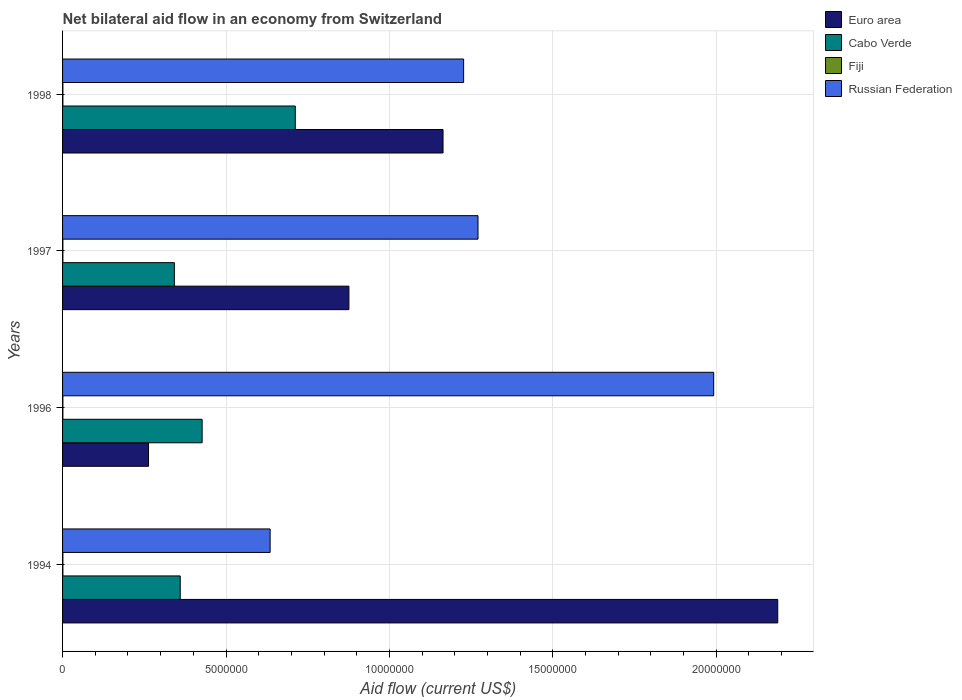How many groups of bars are there?
Offer a very short reply. 4. Are the number of bars per tick equal to the number of legend labels?
Provide a short and direct response. Yes. Are the number of bars on each tick of the Y-axis equal?
Provide a succinct answer. Yes. What is the label of the 4th group of bars from the top?
Keep it short and to the point. 1994. In how many cases, is the number of bars for a given year not equal to the number of legend labels?
Your answer should be compact. 0. What is the net bilateral aid flow in Fiji in 1996?
Offer a very short reply. 10000. Across all years, what is the maximum net bilateral aid flow in Russian Federation?
Give a very brief answer. 1.99e+07. Across all years, what is the minimum net bilateral aid flow in Cabo Verde?
Offer a terse response. 3.42e+06. In which year was the net bilateral aid flow in Fiji minimum?
Make the answer very short. 1994. What is the total net bilateral aid flow in Cabo Verde in the graph?
Your response must be concise. 1.84e+07. What is the difference between the net bilateral aid flow in Euro area in 1994 and that in 1996?
Your answer should be compact. 1.92e+07. What is the difference between the net bilateral aid flow in Russian Federation in 1994 and the net bilateral aid flow in Euro area in 1998?
Make the answer very short. -5.29e+06. What is the average net bilateral aid flow in Fiji per year?
Provide a succinct answer. 10000. In the year 1998, what is the difference between the net bilateral aid flow in Russian Federation and net bilateral aid flow in Euro area?
Provide a short and direct response. 6.30e+05. In how many years, is the net bilateral aid flow in Russian Federation greater than 8000000 US$?
Offer a terse response. 3. Is the difference between the net bilateral aid flow in Russian Federation in 1994 and 1997 greater than the difference between the net bilateral aid flow in Euro area in 1994 and 1997?
Offer a terse response. No. What is the difference between the highest and the second highest net bilateral aid flow in Cabo Verde?
Give a very brief answer. 2.85e+06. What is the difference between the highest and the lowest net bilateral aid flow in Euro area?
Your answer should be very brief. 1.92e+07. In how many years, is the net bilateral aid flow in Cabo Verde greater than the average net bilateral aid flow in Cabo Verde taken over all years?
Make the answer very short. 1. Is it the case that in every year, the sum of the net bilateral aid flow in Fiji and net bilateral aid flow in Cabo Verde is greater than the sum of net bilateral aid flow in Russian Federation and net bilateral aid flow in Euro area?
Make the answer very short. No. What does the 1st bar from the top in 1996 represents?
Ensure brevity in your answer.  Russian Federation. What does the 3rd bar from the bottom in 1997 represents?
Your response must be concise. Fiji. Is it the case that in every year, the sum of the net bilateral aid flow in Cabo Verde and net bilateral aid flow in Russian Federation is greater than the net bilateral aid flow in Fiji?
Give a very brief answer. Yes. Are all the bars in the graph horizontal?
Provide a short and direct response. Yes. Are the values on the major ticks of X-axis written in scientific E-notation?
Provide a succinct answer. No. Where does the legend appear in the graph?
Ensure brevity in your answer.  Top right. How are the legend labels stacked?
Provide a succinct answer. Vertical. What is the title of the graph?
Give a very brief answer. Net bilateral aid flow in an economy from Switzerland. What is the label or title of the X-axis?
Make the answer very short. Aid flow (current US$). What is the Aid flow (current US$) in Euro area in 1994?
Your answer should be very brief. 2.19e+07. What is the Aid flow (current US$) in Cabo Verde in 1994?
Give a very brief answer. 3.60e+06. What is the Aid flow (current US$) of Russian Federation in 1994?
Give a very brief answer. 6.35e+06. What is the Aid flow (current US$) of Euro area in 1996?
Provide a short and direct response. 2.63e+06. What is the Aid flow (current US$) in Cabo Verde in 1996?
Your answer should be compact. 4.27e+06. What is the Aid flow (current US$) in Russian Federation in 1996?
Offer a very short reply. 1.99e+07. What is the Aid flow (current US$) in Euro area in 1997?
Offer a terse response. 8.76e+06. What is the Aid flow (current US$) in Cabo Verde in 1997?
Provide a short and direct response. 3.42e+06. What is the Aid flow (current US$) of Fiji in 1997?
Offer a very short reply. 10000. What is the Aid flow (current US$) of Russian Federation in 1997?
Your response must be concise. 1.27e+07. What is the Aid flow (current US$) of Euro area in 1998?
Provide a succinct answer. 1.16e+07. What is the Aid flow (current US$) of Cabo Verde in 1998?
Ensure brevity in your answer.  7.12e+06. What is the Aid flow (current US$) of Russian Federation in 1998?
Offer a very short reply. 1.23e+07. Across all years, what is the maximum Aid flow (current US$) in Euro area?
Your answer should be very brief. 2.19e+07. Across all years, what is the maximum Aid flow (current US$) in Cabo Verde?
Make the answer very short. 7.12e+06. Across all years, what is the maximum Aid flow (current US$) in Russian Federation?
Give a very brief answer. 1.99e+07. Across all years, what is the minimum Aid flow (current US$) of Euro area?
Your answer should be very brief. 2.63e+06. Across all years, what is the minimum Aid flow (current US$) of Cabo Verde?
Offer a terse response. 3.42e+06. Across all years, what is the minimum Aid flow (current US$) of Russian Federation?
Offer a terse response. 6.35e+06. What is the total Aid flow (current US$) of Euro area in the graph?
Provide a succinct answer. 4.49e+07. What is the total Aid flow (current US$) of Cabo Verde in the graph?
Offer a very short reply. 1.84e+07. What is the total Aid flow (current US$) of Fiji in the graph?
Provide a succinct answer. 4.00e+04. What is the total Aid flow (current US$) of Russian Federation in the graph?
Keep it short and to the point. 5.12e+07. What is the difference between the Aid flow (current US$) of Euro area in 1994 and that in 1996?
Your answer should be compact. 1.92e+07. What is the difference between the Aid flow (current US$) in Cabo Verde in 1994 and that in 1996?
Provide a short and direct response. -6.70e+05. What is the difference between the Aid flow (current US$) in Fiji in 1994 and that in 1996?
Your answer should be very brief. 0. What is the difference between the Aid flow (current US$) of Russian Federation in 1994 and that in 1996?
Keep it short and to the point. -1.36e+07. What is the difference between the Aid flow (current US$) in Euro area in 1994 and that in 1997?
Make the answer very short. 1.31e+07. What is the difference between the Aid flow (current US$) in Russian Federation in 1994 and that in 1997?
Provide a short and direct response. -6.36e+06. What is the difference between the Aid flow (current US$) of Euro area in 1994 and that in 1998?
Offer a terse response. 1.02e+07. What is the difference between the Aid flow (current US$) in Cabo Verde in 1994 and that in 1998?
Keep it short and to the point. -3.52e+06. What is the difference between the Aid flow (current US$) of Fiji in 1994 and that in 1998?
Provide a short and direct response. 0. What is the difference between the Aid flow (current US$) of Russian Federation in 1994 and that in 1998?
Your response must be concise. -5.92e+06. What is the difference between the Aid flow (current US$) in Euro area in 1996 and that in 1997?
Give a very brief answer. -6.13e+06. What is the difference between the Aid flow (current US$) in Cabo Verde in 1996 and that in 1997?
Make the answer very short. 8.50e+05. What is the difference between the Aid flow (current US$) in Russian Federation in 1996 and that in 1997?
Offer a terse response. 7.21e+06. What is the difference between the Aid flow (current US$) in Euro area in 1996 and that in 1998?
Ensure brevity in your answer.  -9.01e+06. What is the difference between the Aid flow (current US$) of Cabo Verde in 1996 and that in 1998?
Offer a terse response. -2.85e+06. What is the difference between the Aid flow (current US$) of Fiji in 1996 and that in 1998?
Make the answer very short. 0. What is the difference between the Aid flow (current US$) in Russian Federation in 1996 and that in 1998?
Provide a short and direct response. 7.65e+06. What is the difference between the Aid flow (current US$) in Euro area in 1997 and that in 1998?
Provide a short and direct response. -2.88e+06. What is the difference between the Aid flow (current US$) of Cabo Verde in 1997 and that in 1998?
Offer a very short reply. -3.70e+06. What is the difference between the Aid flow (current US$) in Fiji in 1997 and that in 1998?
Your response must be concise. 0. What is the difference between the Aid flow (current US$) of Russian Federation in 1997 and that in 1998?
Make the answer very short. 4.40e+05. What is the difference between the Aid flow (current US$) of Euro area in 1994 and the Aid flow (current US$) of Cabo Verde in 1996?
Keep it short and to the point. 1.76e+07. What is the difference between the Aid flow (current US$) of Euro area in 1994 and the Aid flow (current US$) of Fiji in 1996?
Provide a short and direct response. 2.19e+07. What is the difference between the Aid flow (current US$) in Euro area in 1994 and the Aid flow (current US$) in Russian Federation in 1996?
Ensure brevity in your answer.  1.96e+06. What is the difference between the Aid flow (current US$) in Cabo Verde in 1994 and the Aid flow (current US$) in Fiji in 1996?
Keep it short and to the point. 3.59e+06. What is the difference between the Aid flow (current US$) of Cabo Verde in 1994 and the Aid flow (current US$) of Russian Federation in 1996?
Your response must be concise. -1.63e+07. What is the difference between the Aid flow (current US$) in Fiji in 1994 and the Aid flow (current US$) in Russian Federation in 1996?
Make the answer very short. -1.99e+07. What is the difference between the Aid flow (current US$) in Euro area in 1994 and the Aid flow (current US$) in Cabo Verde in 1997?
Ensure brevity in your answer.  1.85e+07. What is the difference between the Aid flow (current US$) of Euro area in 1994 and the Aid flow (current US$) of Fiji in 1997?
Make the answer very short. 2.19e+07. What is the difference between the Aid flow (current US$) of Euro area in 1994 and the Aid flow (current US$) of Russian Federation in 1997?
Give a very brief answer. 9.17e+06. What is the difference between the Aid flow (current US$) of Cabo Verde in 1994 and the Aid flow (current US$) of Fiji in 1997?
Your response must be concise. 3.59e+06. What is the difference between the Aid flow (current US$) of Cabo Verde in 1994 and the Aid flow (current US$) of Russian Federation in 1997?
Your response must be concise. -9.11e+06. What is the difference between the Aid flow (current US$) in Fiji in 1994 and the Aid flow (current US$) in Russian Federation in 1997?
Provide a succinct answer. -1.27e+07. What is the difference between the Aid flow (current US$) of Euro area in 1994 and the Aid flow (current US$) of Cabo Verde in 1998?
Give a very brief answer. 1.48e+07. What is the difference between the Aid flow (current US$) in Euro area in 1994 and the Aid flow (current US$) in Fiji in 1998?
Make the answer very short. 2.19e+07. What is the difference between the Aid flow (current US$) of Euro area in 1994 and the Aid flow (current US$) of Russian Federation in 1998?
Your answer should be very brief. 9.61e+06. What is the difference between the Aid flow (current US$) in Cabo Verde in 1994 and the Aid flow (current US$) in Fiji in 1998?
Ensure brevity in your answer.  3.59e+06. What is the difference between the Aid flow (current US$) in Cabo Verde in 1994 and the Aid flow (current US$) in Russian Federation in 1998?
Your answer should be very brief. -8.67e+06. What is the difference between the Aid flow (current US$) of Fiji in 1994 and the Aid flow (current US$) of Russian Federation in 1998?
Offer a very short reply. -1.23e+07. What is the difference between the Aid flow (current US$) in Euro area in 1996 and the Aid flow (current US$) in Cabo Verde in 1997?
Your answer should be very brief. -7.90e+05. What is the difference between the Aid flow (current US$) of Euro area in 1996 and the Aid flow (current US$) of Fiji in 1997?
Keep it short and to the point. 2.62e+06. What is the difference between the Aid flow (current US$) of Euro area in 1996 and the Aid flow (current US$) of Russian Federation in 1997?
Give a very brief answer. -1.01e+07. What is the difference between the Aid flow (current US$) of Cabo Verde in 1996 and the Aid flow (current US$) of Fiji in 1997?
Offer a terse response. 4.26e+06. What is the difference between the Aid flow (current US$) of Cabo Verde in 1996 and the Aid flow (current US$) of Russian Federation in 1997?
Your answer should be compact. -8.44e+06. What is the difference between the Aid flow (current US$) of Fiji in 1996 and the Aid flow (current US$) of Russian Federation in 1997?
Give a very brief answer. -1.27e+07. What is the difference between the Aid flow (current US$) of Euro area in 1996 and the Aid flow (current US$) of Cabo Verde in 1998?
Provide a succinct answer. -4.49e+06. What is the difference between the Aid flow (current US$) in Euro area in 1996 and the Aid flow (current US$) in Fiji in 1998?
Provide a short and direct response. 2.62e+06. What is the difference between the Aid flow (current US$) in Euro area in 1996 and the Aid flow (current US$) in Russian Federation in 1998?
Provide a succinct answer. -9.64e+06. What is the difference between the Aid flow (current US$) of Cabo Verde in 1996 and the Aid flow (current US$) of Fiji in 1998?
Your answer should be compact. 4.26e+06. What is the difference between the Aid flow (current US$) in Cabo Verde in 1996 and the Aid flow (current US$) in Russian Federation in 1998?
Give a very brief answer. -8.00e+06. What is the difference between the Aid flow (current US$) of Fiji in 1996 and the Aid flow (current US$) of Russian Federation in 1998?
Make the answer very short. -1.23e+07. What is the difference between the Aid flow (current US$) of Euro area in 1997 and the Aid flow (current US$) of Cabo Verde in 1998?
Make the answer very short. 1.64e+06. What is the difference between the Aid flow (current US$) in Euro area in 1997 and the Aid flow (current US$) in Fiji in 1998?
Offer a terse response. 8.75e+06. What is the difference between the Aid flow (current US$) of Euro area in 1997 and the Aid flow (current US$) of Russian Federation in 1998?
Your response must be concise. -3.51e+06. What is the difference between the Aid flow (current US$) in Cabo Verde in 1997 and the Aid flow (current US$) in Fiji in 1998?
Your response must be concise. 3.41e+06. What is the difference between the Aid flow (current US$) in Cabo Verde in 1997 and the Aid flow (current US$) in Russian Federation in 1998?
Offer a very short reply. -8.85e+06. What is the difference between the Aid flow (current US$) of Fiji in 1997 and the Aid flow (current US$) of Russian Federation in 1998?
Offer a very short reply. -1.23e+07. What is the average Aid flow (current US$) in Euro area per year?
Your answer should be very brief. 1.12e+07. What is the average Aid flow (current US$) in Cabo Verde per year?
Make the answer very short. 4.60e+06. What is the average Aid flow (current US$) of Russian Federation per year?
Your answer should be compact. 1.28e+07. In the year 1994, what is the difference between the Aid flow (current US$) in Euro area and Aid flow (current US$) in Cabo Verde?
Your answer should be compact. 1.83e+07. In the year 1994, what is the difference between the Aid flow (current US$) in Euro area and Aid flow (current US$) in Fiji?
Provide a short and direct response. 2.19e+07. In the year 1994, what is the difference between the Aid flow (current US$) of Euro area and Aid flow (current US$) of Russian Federation?
Give a very brief answer. 1.55e+07. In the year 1994, what is the difference between the Aid flow (current US$) of Cabo Verde and Aid flow (current US$) of Fiji?
Your answer should be compact. 3.59e+06. In the year 1994, what is the difference between the Aid flow (current US$) of Cabo Verde and Aid flow (current US$) of Russian Federation?
Your answer should be very brief. -2.75e+06. In the year 1994, what is the difference between the Aid flow (current US$) of Fiji and Aid flow (current US$) of Russian Federation?
Ensure brevity in your answer.  -6.34e+06. In the year 1996, what is the difference between the Aid flow (current US$) in Euro area and Aid flow (current US$) in Cabo Verde?
Your response must be concise. -1.64e+06. In the year 1996, what is the difference between the Aid flow (current US$) of Euro area and Aid flow (current US$) of Fiji?
Offer a very short reply. 2.62e+06. In the year 1996, what is the difference between the Aid flow (current US$) of Euro area and Aid flow (current US$) of Russian Federation?
Provide a short and direct response. -1.73e+07. In the year 1996, what is the difference between the Aid flow (current US$) in Cabo Verde and Aid flow (current US$) in Fiji?
Ensure brevity in your answer.  4.26e+06. In the year 1996, what is the difference between the Aid flow (current US$) in Cabo Verde and Aid flow (current US$) in Russian Federation?
Provide a succinct answer. -1.56e+07. In the year 1996, what is the difference between the Aid flow (current US$) of Fiji and Aid flow (current US$) of Russian Federation?
Your answer should be very brief. -1.99e+07. In the year 1997, what is the difference between the Aid flow (current US$) of Euro area and Aid flow (current US$) of Cabo Verde?
Keep it short and to the point. 5.34e+06. In the year 1997, what is the difference between the Aid flow (current US$) of Euro area and Aid flow (current US$) of Fiji?
Give a very brief answer. 8.75e+06. In the year 1997, what is the difference between the Aid flow (current US$) in Euro area and Aid flow (current US$) in Russian Federation?
Give a very brief answer. -3.95e+06. In the year 1997, what is the difference between the Aid flow (current US$) in Cabo Verde and Aid flow (current US$) in Fiji?
Your answer should be compact. 3.41e+06. In the year 1997, what is the difference between the Aid flow (current US$) in Cabo Verde and Aid flow (current US$) in Russian Federation?
Provide a short and direct response. -9.29e+06. In the year 1997, what is the difference between the Aid flow (current US$) of Fiji and Aid flow (current US$) of Russian Federation?
Keep it short and to the point. -1.27e+07. In the year 1998, what is the difference between the Aid flow (current US$) in Euro area and Aid flow (current US$) in Cabo Verde?
Give a very brief answer. 4.52e+06. In the year 1998, what is the difference between the Aid flow (current US$) in Euro area and Aid flow (current US$) in Fiji?
Provide a succinct answer. 1.16e+07. In the year 1998, what is the difference between the Aid flow (current US$) in Euro area and Aid flow (current US$) in Russian Federation?
Your answer should be very brief. -6.30e+05. In the year 1998, what is the difference between the Aid flow (current US$) in Cabo Verde and Aid flow (current US$) in Fiji?
Ensure brevity in your answer.  7.11e+06. In the year 1998, what is the difference between the Aid flow (current US$) in Cabo Verde and Aid flow (current US$) in Russian Federation?
Your answer should be very brief. -5.15e+06. In the year 1998, what is the difference between the Aid flow (current US$) of Fiji and Aid flow (current US$) of Russian Federation?
Your answer should be very brief. -1.23e+07. What is the ratio of the Aid flow (current US$) in Euro area in 1994 to that in 1996?
Provide a succinct answer. 8.32. What is the ratio of the Aid flow (current US$) in Cabo Verde in 1994 to that in 1996?
Your answer should be very brief. 0.84. What is the ratio of the Aid flow (current US$) in Fiji in 1994 to that in 1996?
Your answer should be compact. 1. What is the ratio of the Aid flow (current US$) in Russian Federation in 1994 to that in 1996?
Provide a succinct answer. 0.32. What is the ratio of the Aid flow (current US$) of Euro area in 1994 to that in 1997?
Your answer should be compact. 2.5. What is the ratio of the Aid flow (current US$) in Cabo Verde in 1994 to that in 1997?
Provide a succinct answer. 1.05. What is the ratio of the Aid flow (current US$) of Fiji in 1994 to that in 1997?
Offer a terse response. 1. What is the ratio of the Aid flow (current US$) in Russian Federation in 1994 to that in 1997?
Ensure brevity in your answer.  0.5. What is the ratio of the Aid flow (current US$) of Euro area in 1994 to that in 1998?
Your answer should be compact. 1.88. What is the ratio of the Aid flow (current US$) of Cabo Verde in 1994 to that in 1998?
Keep it short and to the point. 0.51. What is the ratio of the Aid flow (current US$) of Russian Federation in 1994 to that in 1998?
Offer a terse response. 0.52. What is the ratio of the Aid flow (current US$) of Euro area in 1996 to that in 1997?
Give a very brief answer. 0.3. What is the ratio of the Aid flow (current US$) in Cabo Verde in 1996 to that in 1997?
Give a very brief answer. 1.25. What is the ratio of the Aid flow (current US$) of Russian Federation in 1996 to that in 1997?
Offer a very short reply. 1.57. What is the ratio of the Aid flow (current US$) of Euro area in 1996 to that in 1998?
Ensure brevity in your answer.  0.23. What is the ratio of the Aid flow (current US$) of Cabo Verde in 1996 to that in 1998?
Offer a very short reply. 0.6. What is the ratio of the Aid flow (current US$) of Russian Federation in 1996 to that in 1998?
Give a very brief answer. 1.62. What is the ratio of the Aid flow (current US$) of Euro area in 1997 to that in 1998?
Provide a succinct answer. 0.75. What is the ratio of the Aid flow (current US$) in Cabo Verde in 1997 to that in 1998?
Offer a very short reply. 0.48. What is the ratio of the Aid flow (current US$) of Fiji in 1997 to that in 1998?
Offer a very short reply. 1. What is the ratio of the Aid flow (current US$) in Russian Federation in 1997 to that in 1998?
Provide a short and direct response. 1.04. What is the difference between the highest and the second highest Aid flow (current US$) of Euro area?
Offer a very short reply. 1.02e+07. What is the difference between the highest and the second highest Aid flow (current US$) in Cabo Verde?
Provide a succinct answer. 2.85e+06. What is the difference between the highest and the second highest Aid flow (current US$) of Russian Federation?
Your answer should be compact. 7.21e+06. What is the difference between the highest and the lowest Aid flow (current US$) in Euro area?
Offer a terse response. 1.92e+07. What is the difference between the highest and the lowest Aid flow (current US$) of Cabo Verde?
Provide a short and direct response. 3.70e+06. What is the difference between the highest and the lowest Aid flow (current US$) in Fiji?
Keep it short and to the point. 0. What is the difference between the highest and the lowest Aid flow (current US$) in Russian Federation?
Give a very brief answer. 1.36e+07. 